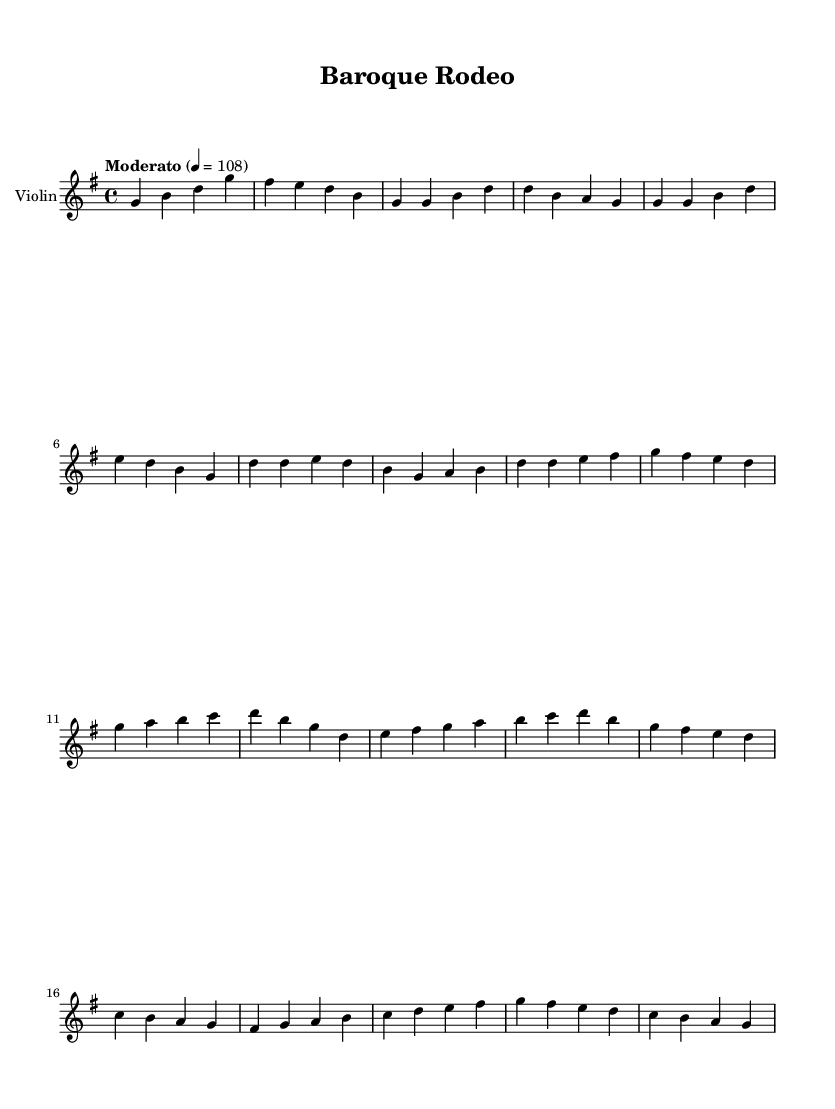What is the key signature of this music? The key signature is G major, which has one sharp (F#). This can be identified by looking at the key signature indicated at the beginning of the music, which shows one sharp.
Answer: G major What is the time signature of this music? The time signature is 4/4. This can be determined by looking at the notation at the beginning of the score, which indicates four beats per measure and a quarter note gets one beat.
Answer: 4/4 What is the tempo marking for this piece? The tempo marking is Moderato, with a metronome indication of 108. You can find this at the beginning of the score under the tempo indication, which specifies how fast the piece should be played.
Answer: Moderato 108 How many measures are in the solo section? There are 4 measures in the solo section. This can be determined by counting the number of grouped notes and bar lines in the section labeled as "Solo."
Answer: 4 What is the highest note in the violin part? The highest note in the violin part is D. By examining the notes in the staff, the highest note in this score appears in the solo section, where the notes ascend, and D is the top note present.
Answer: D Which section includes the chorus? The chorus is included in the section after the verse. The verse is followed by a distinct musical phrasing indicated in the text before the measures that fall under the chorus.
Answer: Chorus What kind of musical influence is featured in this piece? The influence featured in this piece is baroque-inspired. This is evident from the style of the violin solos that reflect characteristics of Baroque music, such as ornamental melodies and elaborate phrasing.
Answer: Baroque-inspired 